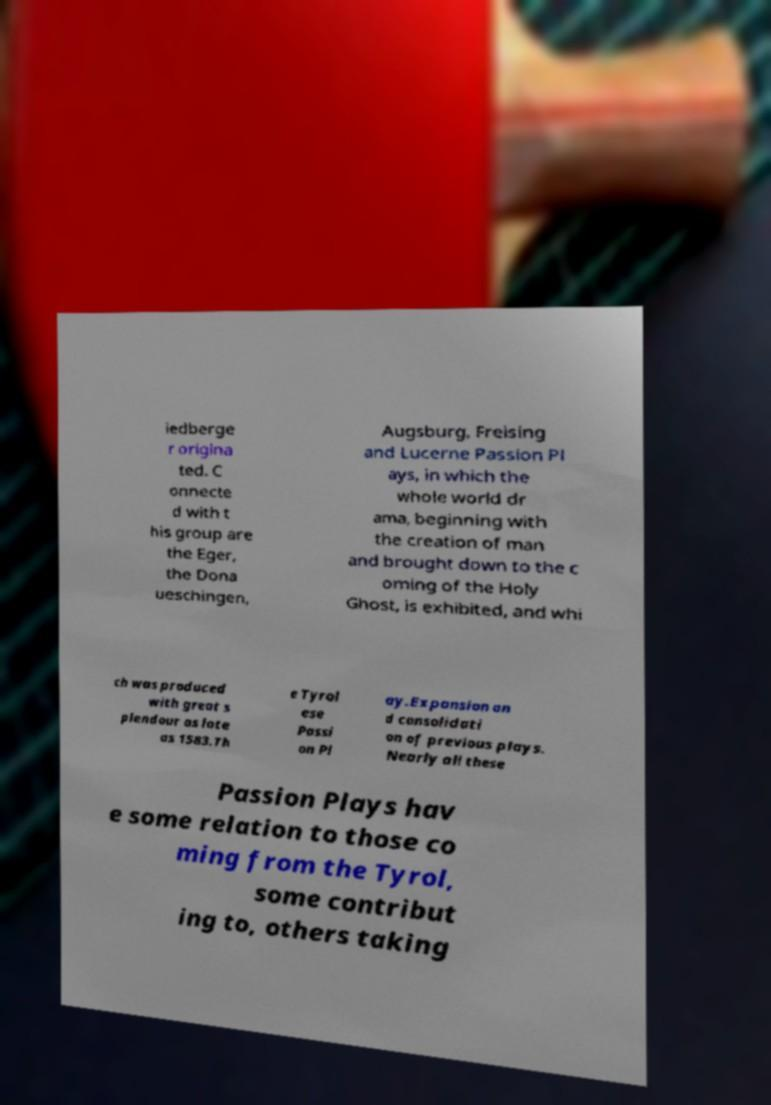Please read and relay the text visible in this image. What does it say? iedberge r origina ted. C onnecte d with t his group are the Eger, the Dona ueschingen, Augsburg, Freising and Lucerne Passion Pl ays, in which the whole world dr ama, beginning with the creation of man and brought down to the c oming of the Holy Ghost, is exhibited, and whi ch was produced with great s plendour as late as 1583.Th e Tyrol ese Passi on Pl ay.Expansion an d consolidati on of previous plays. Nearly all these Passion Plays hav e some relation to those co ming from the Tyrol, some contribut ing to, others taking 